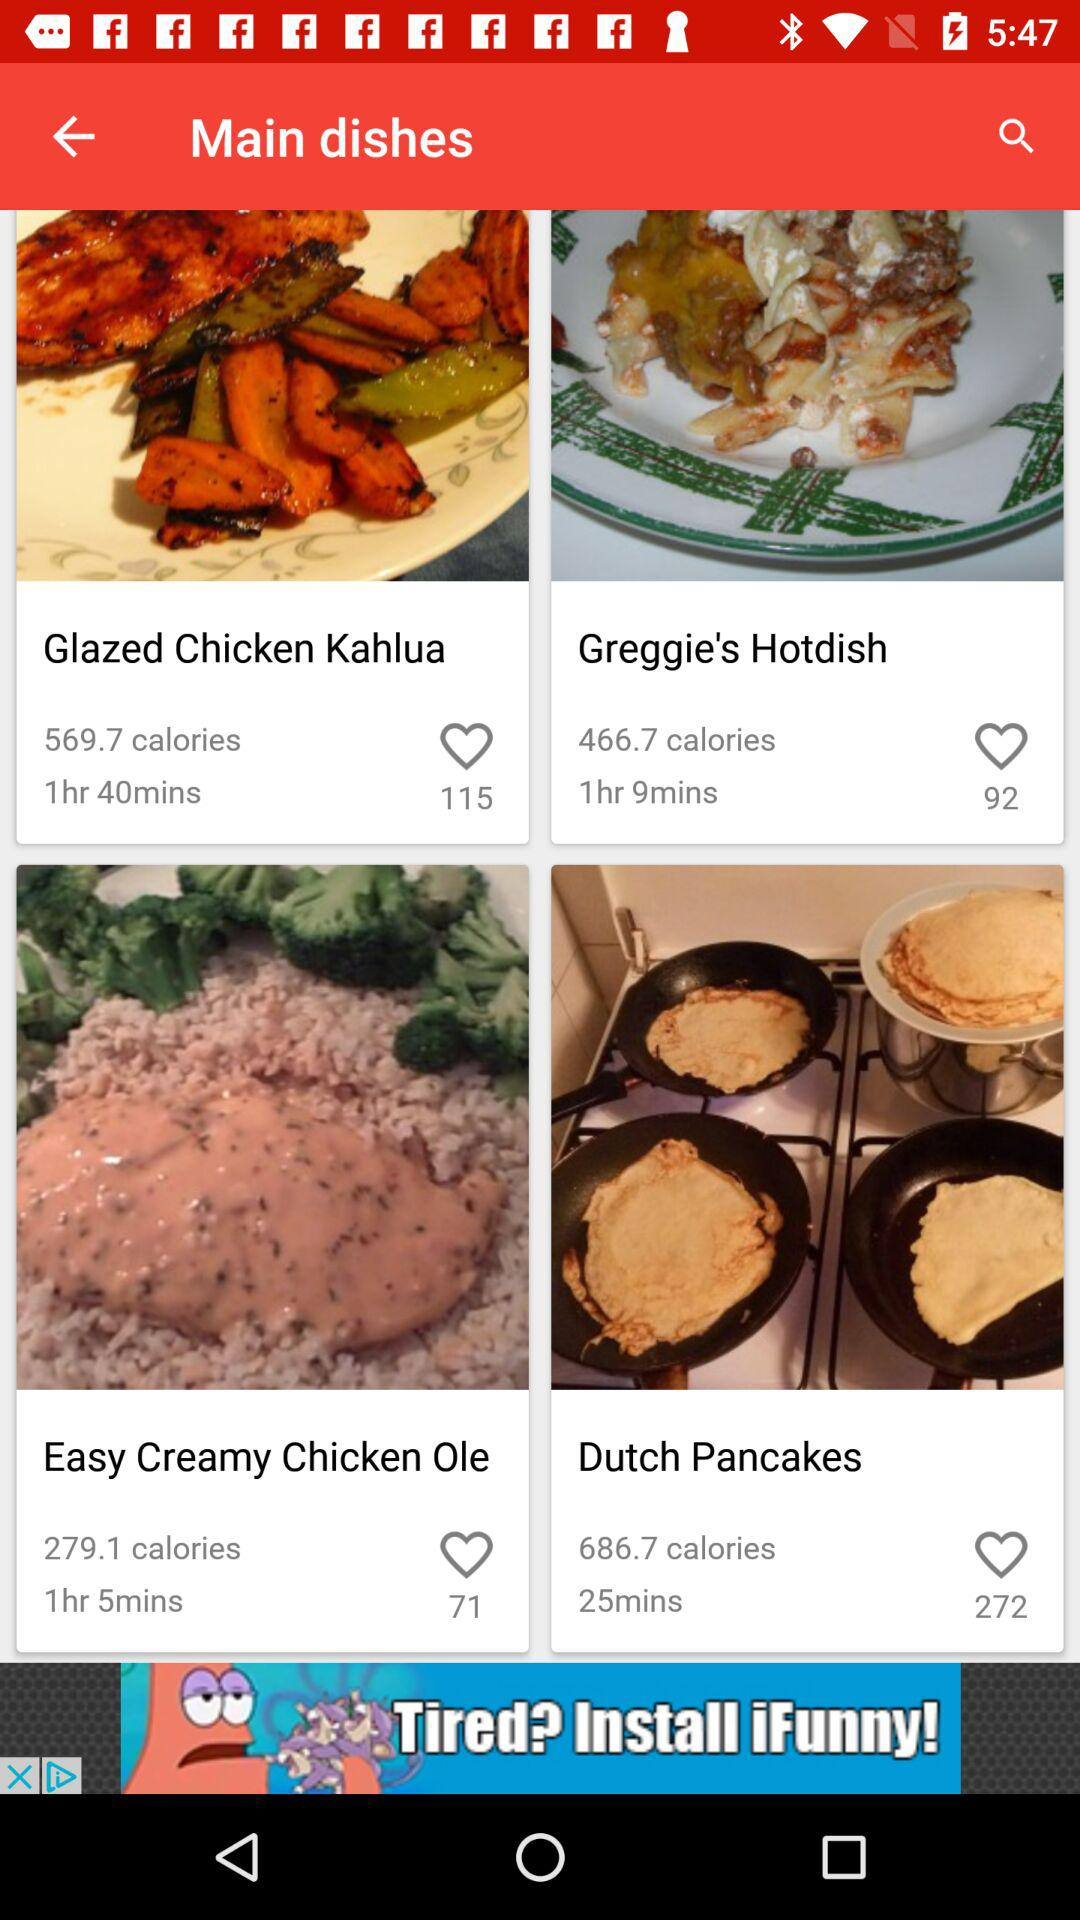How many more calories are in the Glazed Chicken Kahlua than the Greggie's Hotdish?
Answer the question using a single word or phrase. 103 